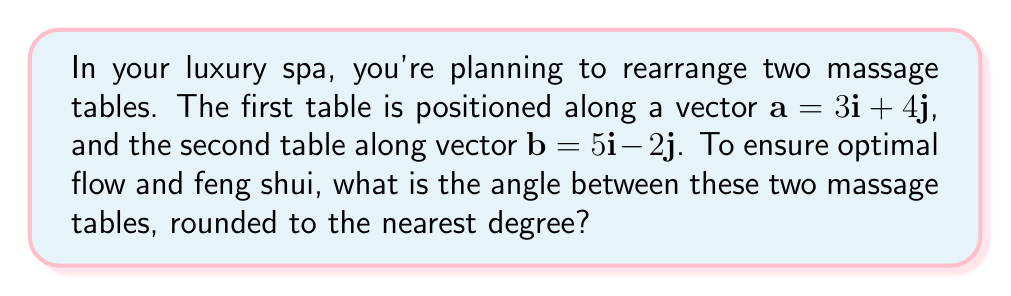Can you answer this question? To find the angle between two vectors, we can use the dot product formula:

$$\cos \theta = \frac{\mathbf{a} \cdot \mathbf{b}}{|\mathbf{a}||\mathbf{b}|}$$

Let's solve this step-by-step:

1) First, calculate the dot product $\mathbf{a} \cdot \mathbf{b}$:
   $\mathbf{a} \cdot \mathbf{b} = (3)(5) + (4)(-2) = 15 - 8 = 7$

2) Calculate the magnitudes of vectors $\mathbf{a}$ and $\mathbf{b}$:
   $|\mathbf{a}| = \sqrt{3^2 + 4^2} = \sqrt{9 + 16} = \sqrt{25} = 5$
   $|\mathbf{b}| = \sqrt{5^2 + (-2)^2} = \sqrt{25 + 4} = \sqrt{29}$

3) Now, substitute these values into the formula:
   $$\cos \theta = \frac{7}{5\sqrt{29}}$$

4) To find $\theta$, we need to take the inverse cosine (arccos) of both sides:
   $$\theta = \arccos(\frac{7}{5\sqrt{29}})$$

5) Using a calculator and rounding to the nearest degree:
   $\theta \approx 66°$
Answer: The angle between the two massage tables is approximately 66°. 